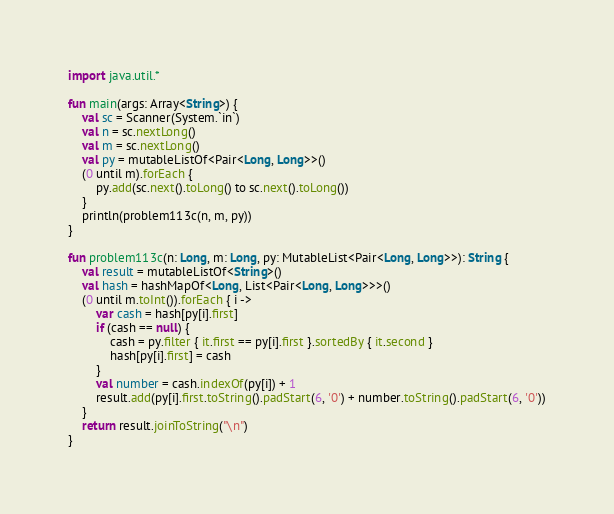Convert code to text. <code><loc_0><loc_0><loc_500><loc_500><_Kotlin_>import java.util.*

fun main(args: Array<String>) {
    val sc = Scanner(System.`in`)
    val n = sc.nextLong()
    val m = sc.nextLong()
    val py = mutableListOf<Pair<Long, Long>>()
    (0 until m).forEach {
        py.add(sc.next().toLong() to sc.next().toLong())
    }
    println(problem113c(n, m, py))
}

fun problem113c(n: Long, m: Long, py: MutableList<Pair<Long, Long>>): String {
    val result = mutableListOf<String>()
    val hash = hashMapOf<Long, List<Pair<Long, Long>>>()
    (0 until m.toInt()).forEach { i ->
        var cash = hash[py[i].first]
        if (cash == null) {
            cash = py.filter { it.first == py[i].first }.sortedBy { it.second }
            hash[py[i].first] = cash
        }
        val number = cash.indexOf(py[i]) + 1
        result.add(py[i].first.toString().padStart(6, '0') + number.toString().padStart(6, '0'))
    }
    return result.joinToString("\n")
}</code> 